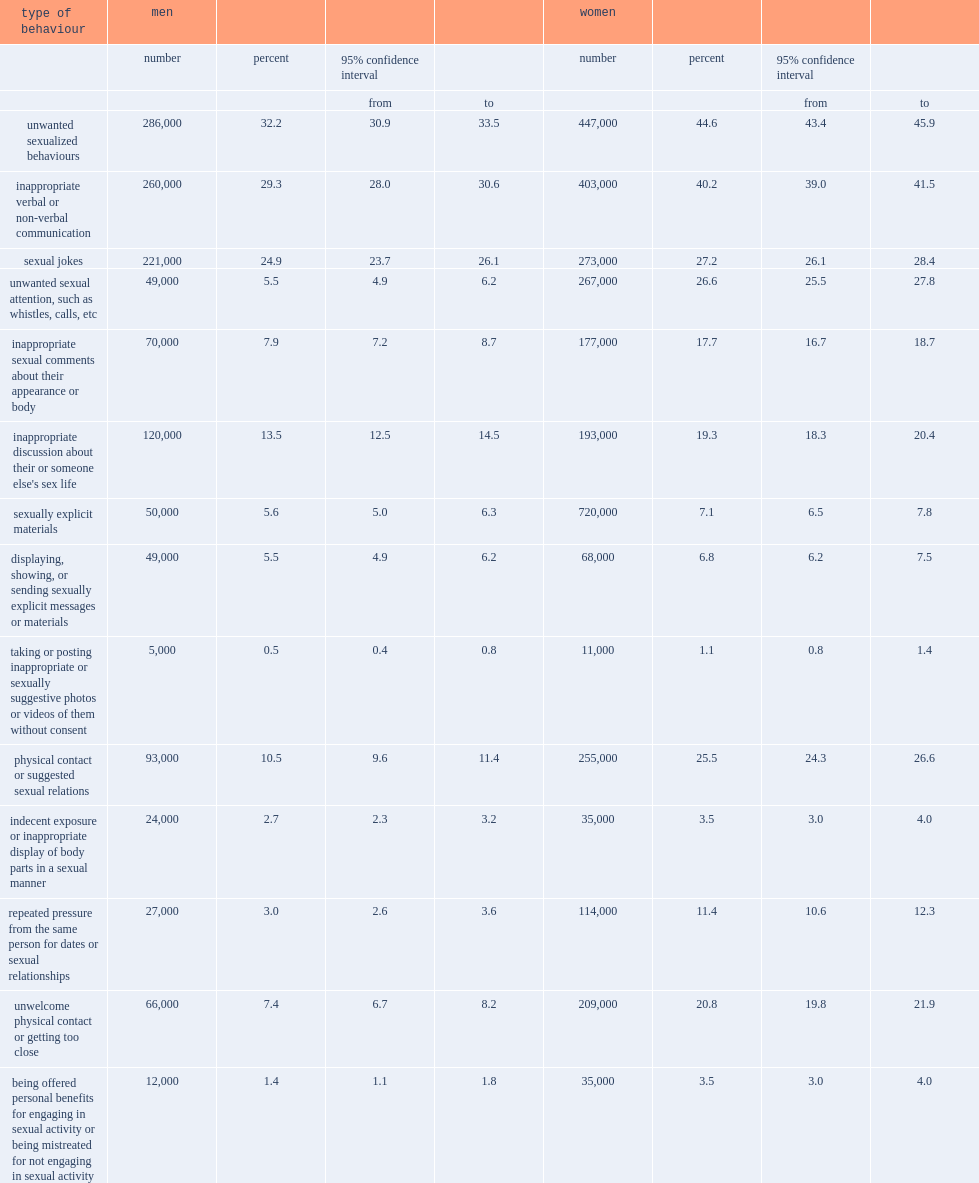How many percent of women reported having personally experienced at least one unwanted sexualized behaviour in the postsecondary setting during the previous 12 months? 44.6. How many percent of men reported having personally experienced at least one unwanted sexualized behaviour in the postsecondary setting during the previous 12 months? 32.2. Sexual jokes were the most common unwanted sexualized behaviour personally experienced by students in the postsecondary setting, how many percent of women? 27.2. Sexual jokes were the most common unwanted sexualized behaviour personally experienced by students in the postsecondary setting, how many percent of men? 24.9. The largest gap between women and men was with respect to unwanted sexual attention, how many percent of women experienced? 26.6. The largest gap between women and men was with respect to unwanted sexual attention, how many percent of men experienced? 5.5. 